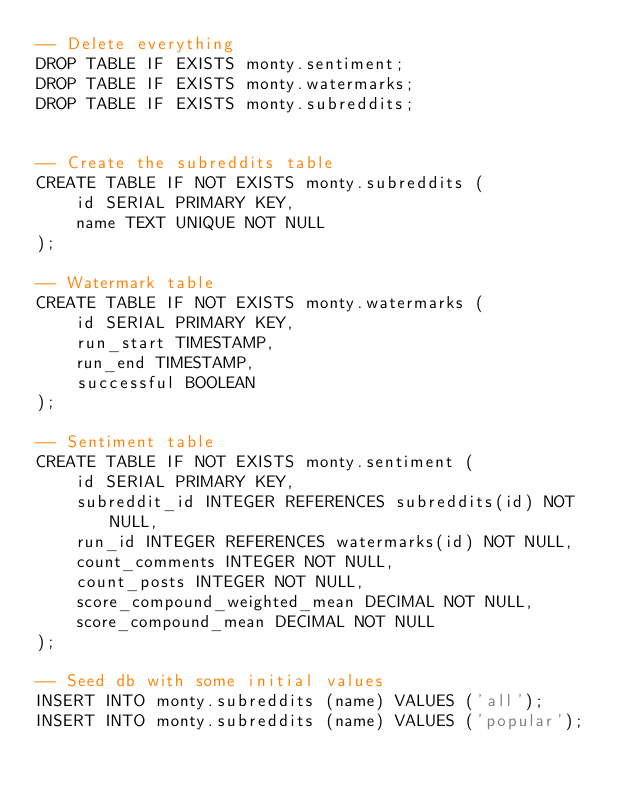<code> <loc_0><loc_0><loc_500><loc_500><_SQL_>-- Delete everything
DROP TABLE IF EXISTS monty.sentiment;
DROP TABLE IF EXISTS monty.watermarks;
DROP TABLE IF EXISTS monty.subreddits;


-- Create the subreddits table
CREATE TABLE IF NOT EXISTS monty.subreddits (
    id SERIAL PRIMARY KEY,
    name TEXT UNIQUE NOT NULL
);

-- Watermark table
CREATE TABLE IF NOT EXISTS monty.watermarks (
    id SERIAL PRIMARY KEY,
    run_start TIMESTAMP,
    run_end TIMESTAMP,
    successful BOOLEAN
);

-- Sentiment table
CREATE TABLE IF NOT EXISTS monty.sentiment (
    id SERIAL PRIMARY KEY,
    subreddit_id INTEGER REFERENCES subreddits(id) NOT NULL,
    run_id INTEGER REFERENCES watermarks(id) NOT NULL,
    count_comments INTEGER NOT NULL,
    count_posts INTEGER NOT NULL,
    score_compound_weighted_mean DECIMAL NOT NULL,
    score_compound_mean DECIMAL NOT NULL
);

-- Seed db with some initial values
INSERT INTO monty.subreddits (name) VALUES ('all');
INSERT INTO monty.subreddits (name) VALUES ('popular');</code> 